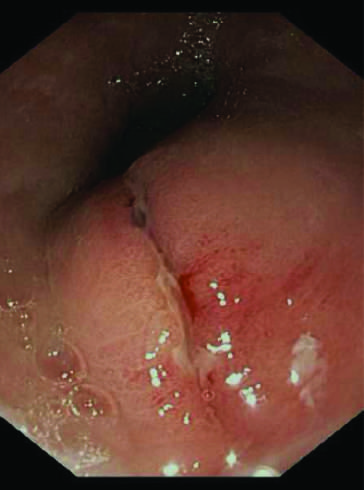does endoscopic view of a longitudinally-oriented mallory-weiss tear?
Answer the question using a single word or phrase. Yes 